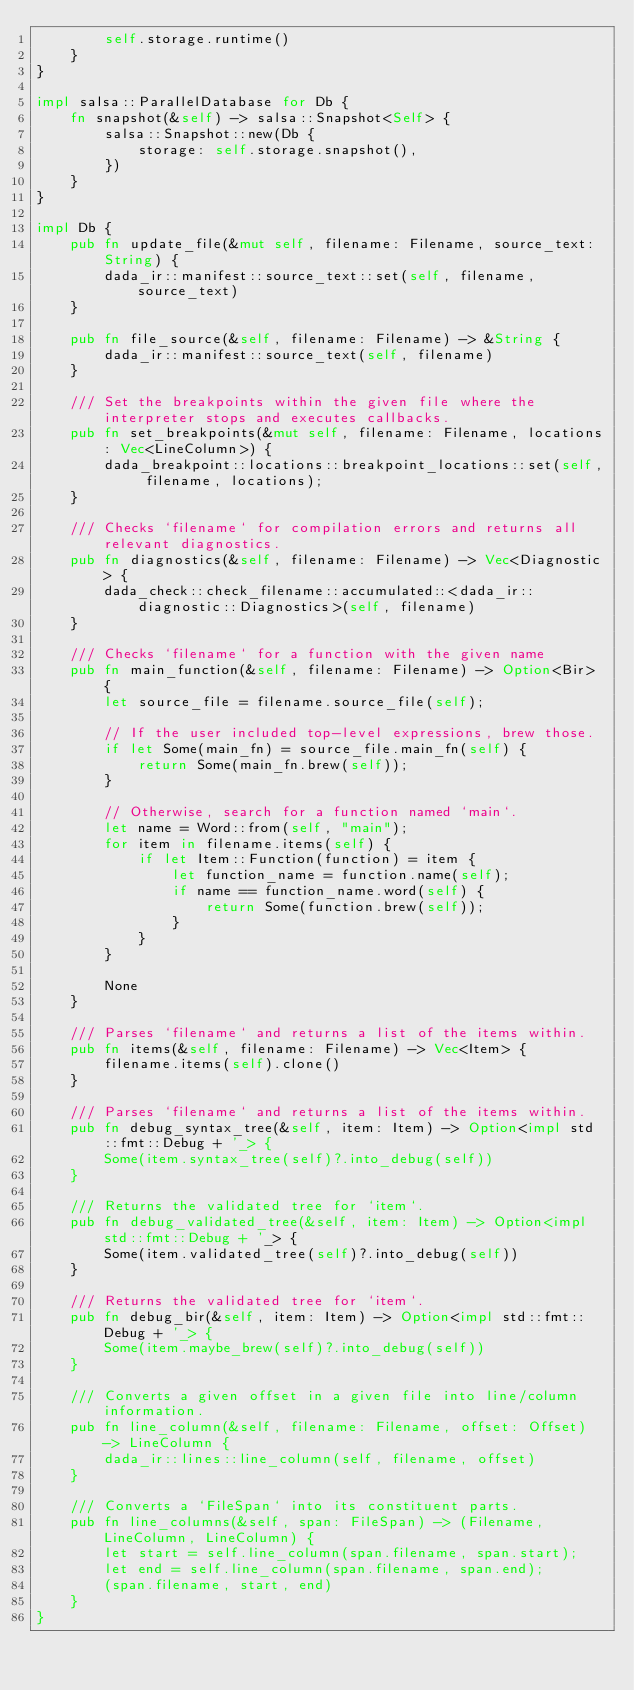Convert code to text. <code><loc_0><loc_0><loc_500><loc_500><_Rust_>        self.storage.runtime()
    }
}

impl salsa::ParallelDatabase for Db {
    fn snapshot(&self) -> salsa::Snapshot<Self> {
        salsa::Snapshot::new(Db {
            storage: self.storage.snapshot(),
        })
    }
}

impl Db {
    pub fn update_file(&mut self, filename: Filename, source_text: String) {
        dada_ir::manifest::source_text::set(self, filename, source_text)
    }

    pub fn file_source(&self, filename: Filename) -> &String {
        dada_ir::manifest::source_text(self, filename)
    }

    /// Set the breakpoints within the given file where the interpreter stops and executes callbacks.
    pub fn set_breakpoints(&mut self, filename: Filename, locations: Vec<LineColumn>) {
        dada_breakpoint::locations::breakpoint_locations::set(self, filename, locations);
    }

    /// Checks `filename` for compilation errors and returns all relevant diagnostics.
    pub fn diagnostics(&self, filename: Filename) -> Vec<Diagnostic> {
        dada_check::check_filename::accumulated::<dada_ir::diagnostic::Diagnostics>(self, filename)
    }

    /// Checks `filename` for a function with the given name
    pub fn main_function(&self, filename: Filename) -> Option<Bir> {
        let source_file = filename.source_file(self);

        // If the user included top-level expressions, brew those.
        if let Some(main_fn) = source_file.main_fn(self) {
            return Some(main_fn.brew(self));
        }

        // Otherwise, search for a function named `main`.
        let name = Word::from(self, "main");
        for item in filename.items(self) {
            if let Item::Function(function) = item {
                let function_name = function.name(self);
                if name == function_name.word(self) {
                    return Some(function.brew(self));
                }
            }
        }

        None
    }

    /// Parses `filename` and returns a list of the items within.
    pub fn items(&self, filename: Filename) -> Vec<Item> {
        filename.items(self).clone()
    }

    /// Parses `filename` and returns a list of the items within.
    pub fn debug_syntax_tree(&self, item: Item) -> Option<impl std::fmt::Debug + '_> {
        Some(item.syntax_tree(self)?.into_debug(self))
    }

    /// Returns the validated tree for `item`.
    pub fn debug_validated_tree(&self, item: Item) -> Option<impl std::fmt::Debug + '_> {
        Some(item.validated_tree(self)?.into_debug(self))
    }

    /// Returns the validated tree for `item`.
    pub fn debug_bir(&self, item: Item) -> Option<impl std::fmt::Debug + '_> {
        Some(item.maybe_brew(self)?.into_debug(self))
    }

    /// Converts a given offset in a given file into line/column information.
    pub fn line_column(&self, filename: Filename, offset: Offset) -> LineColumn {
        dada_ir::lines::line_column(self, filename, offset)
    }

    /// Converts a `FileSpan` into its constituent parts.
    pub fn line_columns(&self, span: FileSpan) -> (Filename, LineColumn, LineColumn) {
        let start = self.line_column(span.filename, span.start);
        let end = self.line_column(span.filename, span.end);
        (span.filename, start, end)
    }
}
</code> 